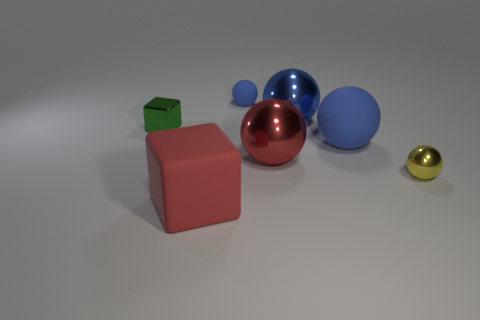Are there fewer large red objects than tiny objects?
Your answer should be compact. Yes. Does the tiny metal object that is left of the red rubber cube have the same shape as the red matte object?
Provide a short and direct response. Yes. Is there a purple rubber cylinder?
Your answer should be compact. No. What color is the small metallic thing that is on the right side of the large blue sphere that is behind the block behind the tiny yellow sphere?
Keep it short and to the point. Yellow. Are there an equal number of things that are to the right of the large red rubber thing and tiny matte spheres that are behind the small blue rubber thing?
Keep it short and to the point. No. There is a red object that is the same size as the red block; what shape is it?
Ensure brevity in your answer.  Sphere. Are there any big rubber things of the same color as the large cube?
Make the answer very short. No. The red metallic object behind the yellow shiny ball has what shape?
Make the answer very short. Sphere. The small block is what color?
Your answer should be very brief. Green. The small thing that is the same material as the big red cube is what color?
Your answer should be compact. Blue. 